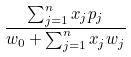<formula> <loc_0><loc_0><loc_500><loc_500>\frac { \sum _ { j = 1 } ^ { n } x _ { j } p _ { j } } { w _ { 0 } + \sum _ { j = 1 } ^ { n } x _ { j } w _ { j } }</formula> 